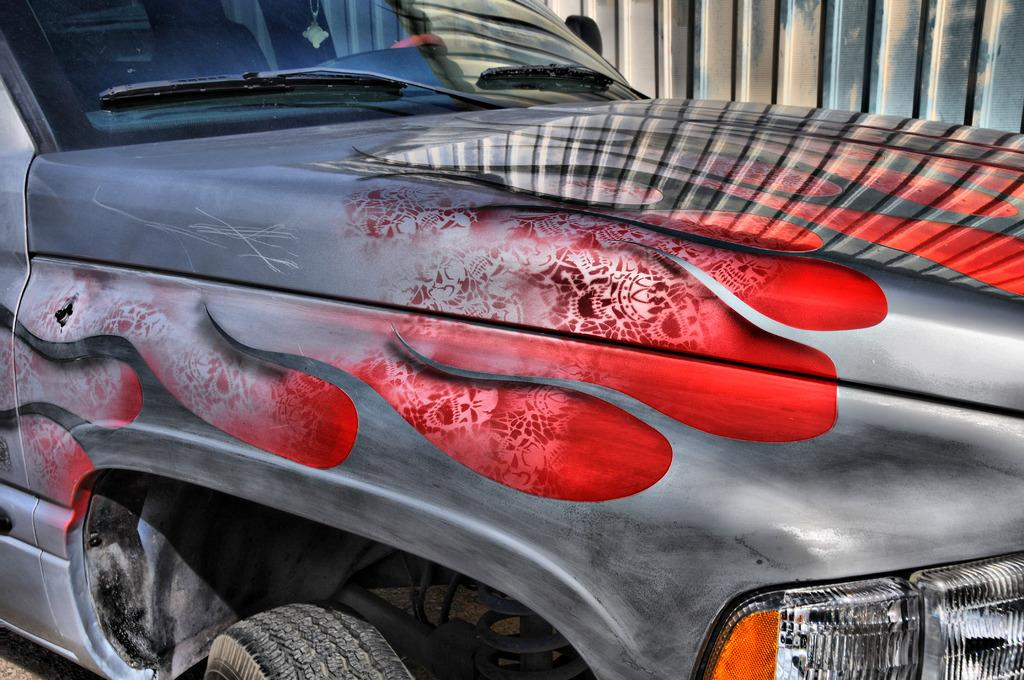What is the main subject of the image? The main subject of the image is a car. Are there any additional features on the car? Yes, the car has stickers on it. What can be seen in the background of the image? There is a wall in the background of the image. How many waves can be seen crashing against the scarecrow in the image? There are no waves or scarecrows present in the image; it features a car with stickers and a wall in the background. 